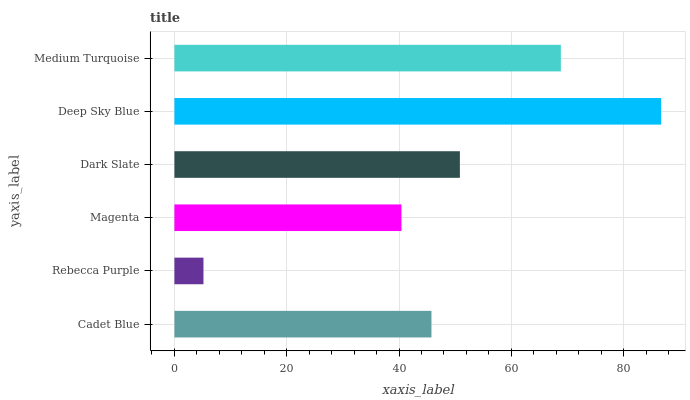Is Rebecca Purple the minimum?
Answer yes or no. Yes. Is Deep Sky Blue the maximum?
Answer yes or no. Yes. Is Magenta the minimum?
Answer yes or no. No. Is Magenta the maximum?
Answer yes or no. No. Is Magenta greater than Rebecca Purple?
Answer yes or no. Yes. Is Rebecca Purple less than Magenta?
Answer yes or no. Yes. Is Rebecca Purple greater than Magenta?
Answer yes or no. No. Is Magenta less than Rebecca Purple?
Answer yes or no. No. Is Dark Slate the high median?
Answer yes or no. Yes. Is Cadet Blue the low median?
Answer yes or no. Yes. Is Medium Turquoise the high median?
Answer yes or no. No. Is Dark Slate the low median?
Answer yes or no. No. 